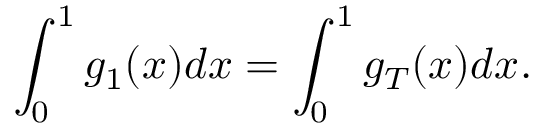<formula> <loc_0><loc_0><loc_500><loc_500>\int _ { 0 } ^ { 1 } g _ { 1 } ( x ) d x = \int _ { 0 } ^ { 1 } g _ { T } ( x ) d x .</formula> 